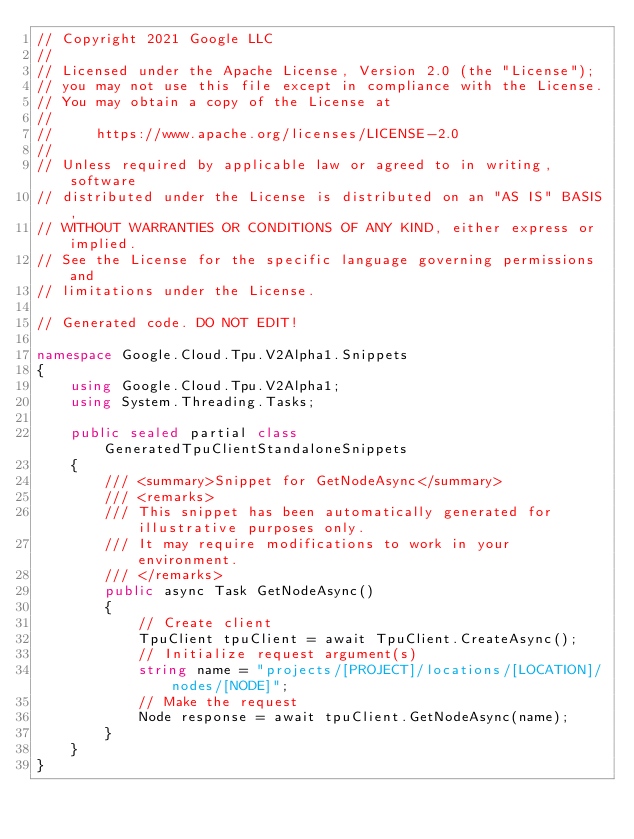Convert code to text. <code><loc_0><loc_0><loc_500><loc_500><_C#_>// Copyright 2021 Google LLC
//
// Licensed under the Apache License, Version 2.0 (the "License");
// you may not use this file except in compliance with the License.
// You may obtain a copy of the License at
//
//     https://www.apache.org/licenses/LICENSE-2.0
//
// Unless required by applicable law or agreed to in writing, software
// distributed under the License is distributed on an "AS IS" BASIS,
// WITHOUT WARRANTIES OR CONDITIONS OF ANY KIND, either express or implied.
// See the License for the specific language governing permissions and
// limitations under the License.

// Generated code. DO NOT EDIT!

namespace Google.Cloud.Tpu.V2Alpha1.Snippets
{
    using Google.Cloud.Tpu.V2Alpha1;
    using System.Threading.Tasks;

    public sealed partial class GeneratedTpuClientStandaloneSnippets
    {
        /// <summary>Snippet for GetNodeAsync</summary>
        /// <remarks>
        /// This snippet has been automatically generated for illustrative purposes only.
        /// It may require modifications to work in your environment.
        /// </remarks>
        public async Task GetNodeAsync()
        {
            // Create client
            TpuClient tpuClient = await TpuClient.CreateAsync();
            // Initialize request argument(s)
            string name = "projects/[PROJECT]/locations/[LOCATION]/nodes/[NODE]";
            // Make the request
            Node response = await tpuClient.GetNodeAsync(name);
        }
    }
}
</code> 